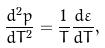<formula> <loc_0><loc_0><loc_500><loc_500>\frac { d ^ { 2 } p } { d T ^ { 2 } } = \frac { 1 } { T } \frac { d \varepsilon } { d T } ,</formula> 